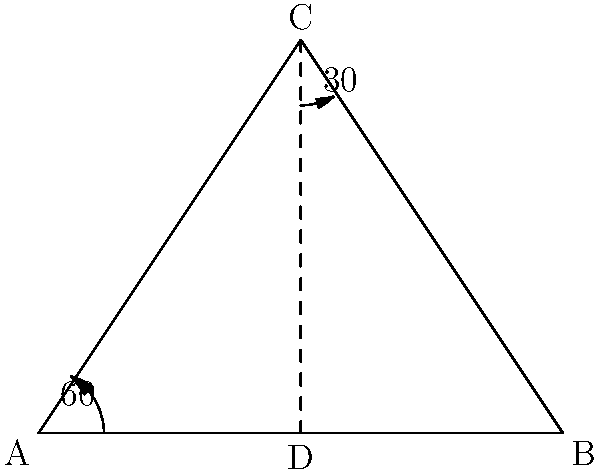At the Cloud Gate sculpture in Millennium Park, the shadow cast by the sun forms a triangle on the ground. If the angle between the ground and the sun's rays is 60°, and the angle between the shadow and the vertical axis of the sculpture is 30°, what is the measure of the angle formed by the shadow and the ground? Let's approach this step-by-step:

1) In the diagram, triangle ABC represents the situation described. 
   - AB is the ground
   - AC is the sun's ray
   - BC is the shadow cast by the sculpture

2) We're given two angles:
   - Angle CAB (between the sun's ray and the ground) is 60°
   - Angle BCA (between the shadow and the vertical axis) is 30°

3) In any triangle, the sum of all angles is always 180°.

4) Let's call the angle we're looking for (angle ABC) as x°.

5) We can set up an equation:
   $60° + 30° + x° = 180°$

6) Simplifying:
   $90° + x° = 180°$

7) Solving for x:
   $x° = 180° - 90° = 90°$

Therefore, the angle formed by the shadow and the ground is 90°.
Answer: 90° 